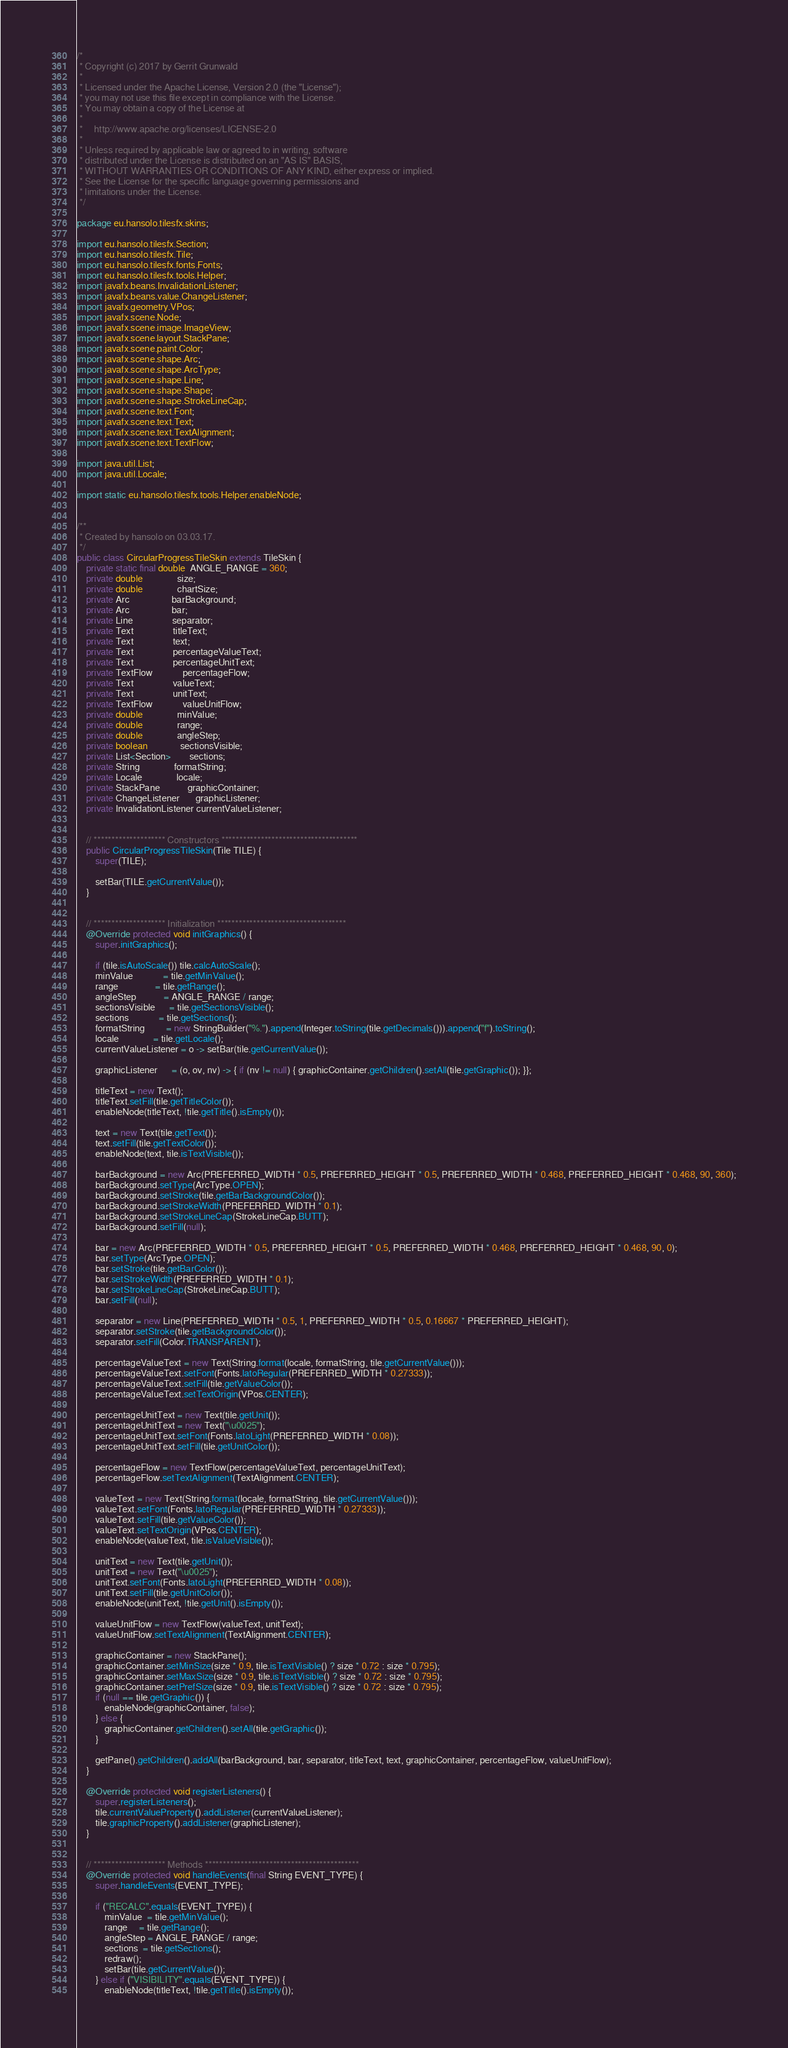Convert code to text. <code><loc_0><loc_0><loc_500><loc_500><_Java_>/*
 * Copyright (c) 2017 by Gerrit Grunwald
 *
 * Licensed under the Apache License, Version 2.0 (the "License");
 * you may not use this file except in compliance with the License.
 * You may obtain a copy of the License at
 *
 *     http://www.apache.org/licenses/LICENSE-2.0
 *
 * Unless required by applicable law or agreed to in writing, software
 * distributed under the License is distributed on an "AS IS" BASIS,
 * WITHOUT WARRANTIES OR CONDITIONS OF ANY KIND, either express or implied.
 * See the License for the specific language governing permissions and
 * limitations under the License.
 */

package eu.hansolo.tilesfx.skins;

import eu.hansolo.tilesfx.Section;
import eu.hansolo.tilesfx.Tile;
import eu.hansolo.tilesfx.fonts.Fonts;
import eu.hansolo.tilesfx.tools.Helper;
import javafx.beans.InvalidationListener;
import javafx.beans.value.ChangeListener;
import javafx.geometry.VPos;
import javafx.scene.Node;
import javafx.scene.image.ImageView;
import javafx.scene.layout.StackPane;
import javafx.scene.paint.Color;
import javafx.scene.shape.Arc;
import javafx.scene.shape.ArcType;
import javafx.scene.shape.Line;
import javafx.scene.shape.Shape;
import javafx.scene.shape.StrokeLineCap;
import javafx.scene.text.Font;
import javafx.scene.text.Text;
import javafx.scene.text.TextAlignment;
import javafx.scene.text.TextFlow;

import java.util.List;
import java.util.Locale;

import static eu.hansolo.tilesfx.tools.Helper.enableNode;


/**
 * Created by hansolo on 03.03.17.
 */
public class CircularProgressTileSkin extends TileSkin {
    private static final double  ANGLE_RANGE = 360;
    private double               size;
    private double               chartSize;
    private Arc                  barBackground;
    private Arc                  bar;
    private Line                 separator;
    private Text                 titleText;
    private Text                 text;
    private Text                 percentageValueText;
    private Text                 percentageUnitText;
    private TextFlow             percentageFlow;
    private Text                 valueText;
    private Text                 unitText;
    private TextFlow             valueUnitFlow;
    private double               minValue;
    private double               range;
    private double               angleStep;
    private boolean              sectionsVisible;
    private List<Section>        sections;
    private String               formatString;
    private Locale               locale;
    private StackPane            graphicContainer;
    private ChangeListener       graphicListener;
    private InvalidationListener currentValueListener;


    // ******************** Constructors **************************************
    public CircularProgressTileSkin(Tile TILE) {
        super(TILE);

        setBar(TILE.getCurrentValue());
    }


    // ******************** Initialization ************************************
    @Override protected void initGraphics() {
        super.initGraphics();

        if (tile.isAutoScale()) tile.calcAutoScale();
        minValue             = tile.getMinValue();
        range                = tile.getRange();
        angleStep            = ANGLE_RANGE / range;
        sectionsVisible      = tile.getSectionsVisible();
        sections             = tile.getSections();
        formatString         = new StringBuilder("%.").append(Integer.toString(tile.getDecimals())).append("f").toString();
        locale               = tile.getLocale();
        currentValueListener = o -> setBar(tile.getCurrentValue());

        graphicListener      = (o, ov, nv) -> { if (nv != null) { graphicContainer.getChildren().setAll(tile.getGraphic()); }};

        titleText = new Text();
        titleText.setFill(tile.getTitleColor());
        enableNode(titleText, !tile.getTitle().isEmpty());

        text = new Text(tile.getText());
        text.setFill(tile.getTextColor());
        enableNode(text, tile.isTextVisible());

        barBackground = new Arc(PREFERRED_WIDTH * 0.5, PREFERRED_HEIGHT * 0.5, PREFERRED_WIDTH * 0.468, PREFERRED_HEIGHT * 0.468, 90, 360);
        barBackground.setType(ArcType.OPEN);
        barBackground.setStroke(tile.getBarBackgroundColor());
        barBackground.setStrokeWidth(PREFERRED_WIDTH * 0.1);
        barBackground.setStrokeLineCap(StrokeLineCap.BUTT);
        barBackground.setFill(null);

        bar = new Arc(PREFERRED_WIDTH * 0.5, PREFERRED_HEIGHT * 0.5, PREFERRED_WIDTH * 0.468, PREFERRED_HEIGHT * 0.468, 90, 0);
        bar.setType(ArcType.OPEN);
        bar.setStroke(tile.getBarColor());
        bar.setStrokeWidth(PREFERRED_WIDTH * 0.1);
        bar.setStrokeLineCap(StrokeLineCap.BUTT);
        bar.setFill(null);

        separator = new Line(PREFERRED_WIDTH * 0.5, 1, PREFERRED_WIDTH * 0.5, 0.16667 * PREFERRED_HEIGHT);
        separator.setStroke(tile.getBackgroundColor());
        separator.setFill(Color.TRANSPARENT);

        percentageValueText = new Text(String.format(locale, formatString, tile.getCurrentValue()));
        percentageValueText.setFont(Fonts.latoRegular(PREFERRED_WIDTH * 0.27333));
        percentageValueText.setFill(tile.getValueColor());
        percentageValueText.setTextOrigin(VPos.CENTER);

        percentageUnitText = new Text(tile.getUnit());
        percentageUnitText = new Text("\u0025");
        percentageUnitText.setFont(Fonts.latoLight(PREFERRED_WIDTH * 0.08));
        percentageUnitText.setFill(tile.getUnitColor());

        percentageFlow = new TextFlow(percentageValueText, percentageUnitText);
        percentageFlow.setTextAlignment(TextAlignment.CENTER);

        valueText = new Text(String.format(locale, formatString, tile.getCurrentValue()));
        valueText.setFont(Fonts.latoRegular(PREFERRED_WIDTH * 0.27333));
        valueText.setFill(tile.getValueColor());
        valueText.setTextOrigin(VPos.CENTER);
        enableNode(valueText, tile.isValueVisible());

        unitText = new Text(tile.getUnit());
        unitText = new Text("\u0025");
        unitText.setFont(Fonts.latoLight(PREFERRED_WIDTH * 0.08));
        unitText.setFill(tile.getUnitColor());
        enableNode(unitText, !tile.getUnit().isEmpty());

        valueUnitFlow = new TextFlow(valueText, unitText);
        valueUnitFlow.setTextAlignment(TextAlignment.CENTER);

        graphicContainer = new StackPane();
        graphicContainer.setMinSize(size * 0.9, tile.isTextVisible() ? size * 0.72 : size * 0.795);
        graphicContainer.setMaxSize(size * 0.9, tile.isTextVisible() ? size * 0.72 : size * 0.795);
        graphicContainer.setPrefSize(size * 0.9, tile.isTextVisible() ? size * 0.72 : size * 0.795);
        if (null == tile.getGraphic()) {
            enableNode(graphicContainer, false);
        } else {
            graphicContainer.getChildren().setAll(tile.getGraphic());
        }

        getPane().getChildren().addAll(barBackground, bar, separator, titleText, text, graphicContainer, percentageFlow, valueUnitFlow);
    }

    @Override protected void registerListeners() {
        super.registerListeners();
        tile.currentValueProperty().addListener(currentValueListener);
        tile.graphicProperty().addListener(graphicListener);
    }


    // ******************** Methods *******************************************
    @Override protected void handleEvents(final String EVENT_TYPE) {
        super.handleEvents(EVENT_TYPE);

        if ("RECALC".equals(EVENT_TYPE)) {
            minValue  = tile.getMinValue();
            range     = tile.getRange();
            angleStep = ANGLE_RANGE / range;
            sections  = tile.getSections();
            redraw();
            setBar(tile.getCurrentValue());
        } else if ("VISIBILITY".equals(EVENT_TYPE)) {
            enableNode(titleText, !tile.getTitle().isEmpty());</code> 